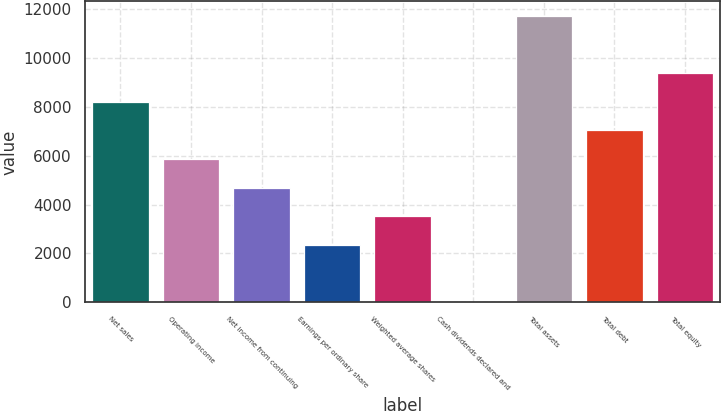Convert chart. <chart><loc_0><loc_0><loc_500><loc_500><bar_chart><fcel>Net sales<fcel>Operating income<fcel>Net income from continuing<fcel>Earnings per ordinary share<fcel>Weighted average shares<fcel>Cash dividends declared and<fcel>Total assets<fcel>Total debt<fcel>Total equity<nl><fcel>8212.9<fcel>5866.5<fcel>4693.3<fcel>2346.9<fcel>3520.1<fcel>0.5<fcel>11732.5<fcel>7039.7<fcel>9386.1<nl></chart> 